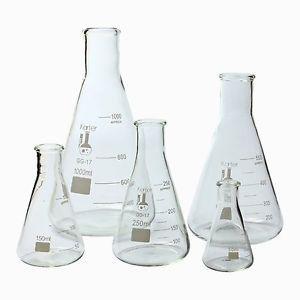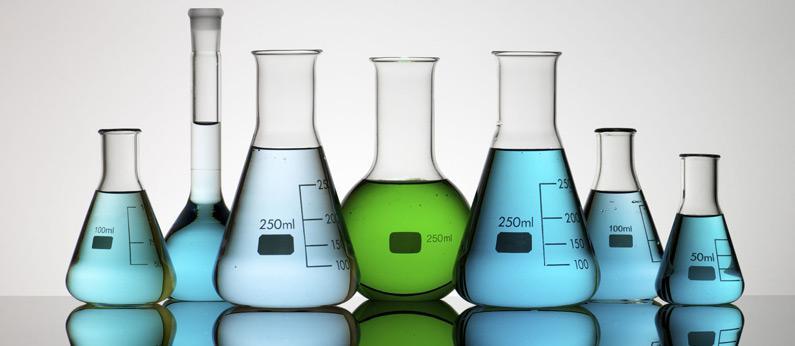The first image is the image on the left, the second image is the image on the right. Analyze the images presented: Is the assertion "In the image to the right, one of the flasks holds a yellow liquid." valid? Answer yes or no. No. The first image is the image on the left, the second image is the image on the right. Assess this claim about the two images: "All the containers have liquid in them.". Correct or not? Answer yes or no. No. 